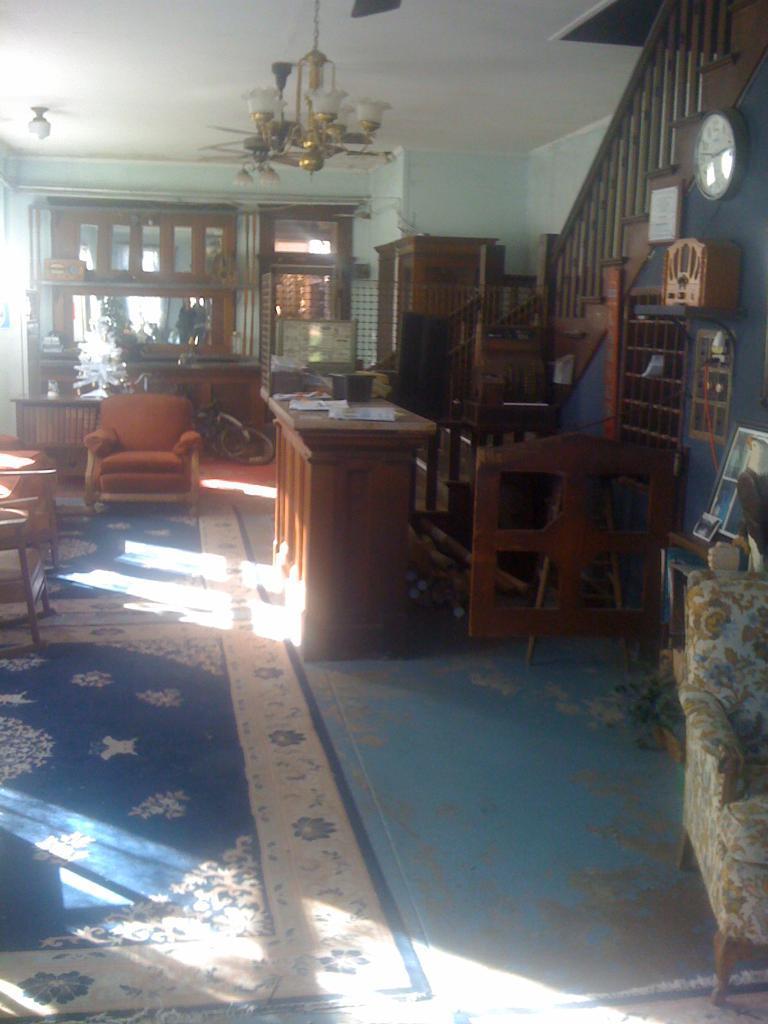In one or two sentences, can you explain what this image depicts? In this image I can see the inner view of the building. Inside the building I can see the couch and the teapoy. To the right I can see an another couch and the few objects on the table. I can see the board, clock and an object to the wall. I can see the railing. In the background I can see few more objects. There is a chandelier light at the top. 